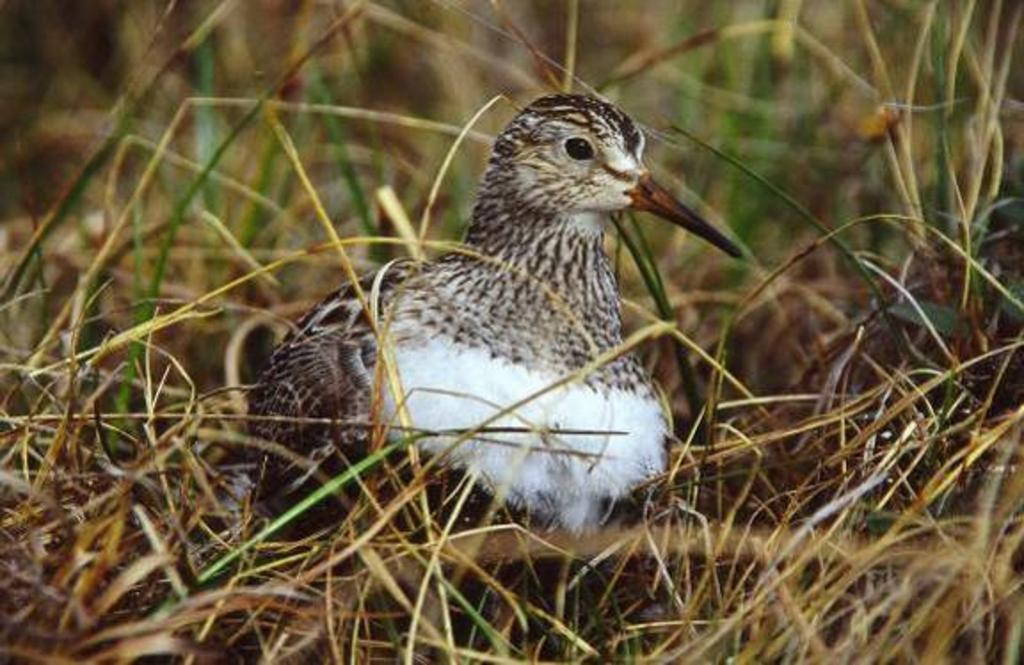What type of animal can be seen in the image? There is a bird in the image. Where is the bird located? The bird is sitting on dry grass. Can you describe the background of the image? The background of the image is blurred. What ideas does the bird have about the future of the cattle in the image? There are no cattle present in the image, and therefore no such interaction or ideas can be observed. 